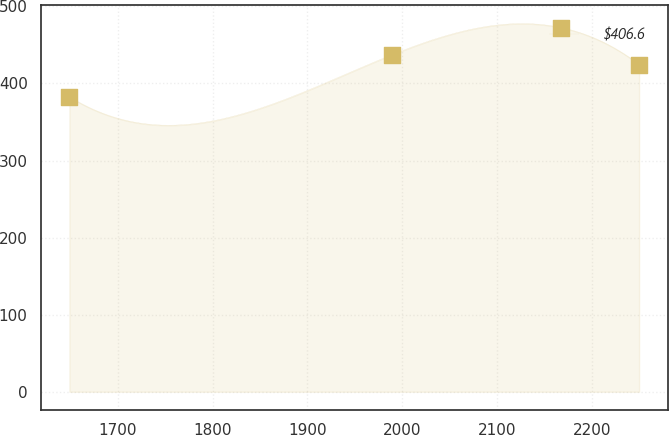Convert chart. <chart><loc_0><loc_0><loc_500><loc_500><line_chart><ecel><fcel>$406.6<nl><fcel>1649<fcel>382.72<nl><fcel>1988.89<fcel>437.06<nl><fcel>2167.88<fcel>472.38<nl><fcel>2250.07<fcel>424.51<nl></chart> 